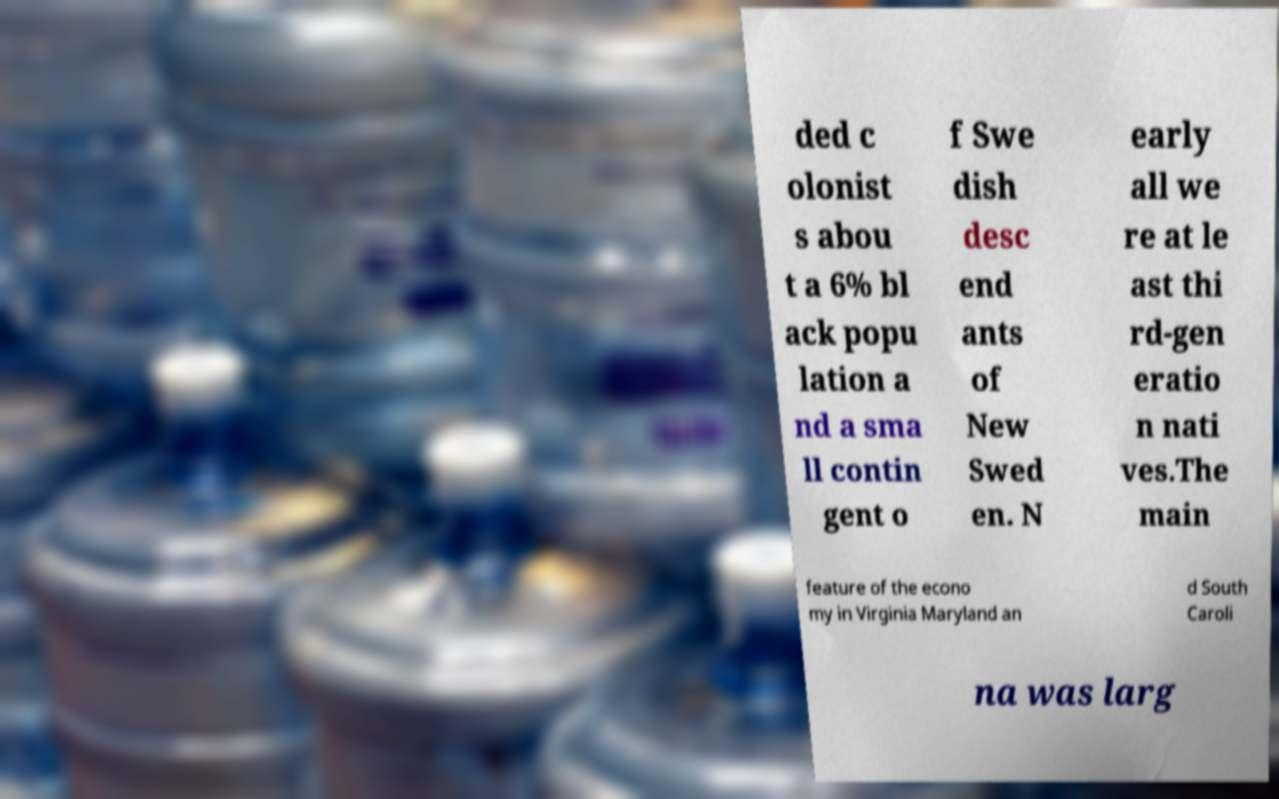Could you extract and type out the text from this image? ded c olonist s abou t a 6% bl ack popu lation a nd a sma ll contin gent o f Swe dish desc end ants of New Swed en. N early all we re at le ast thi rd-gen eratio n nati ves.The main feature of the econo my in Virginia Maryland an d South Caroli na was larg 